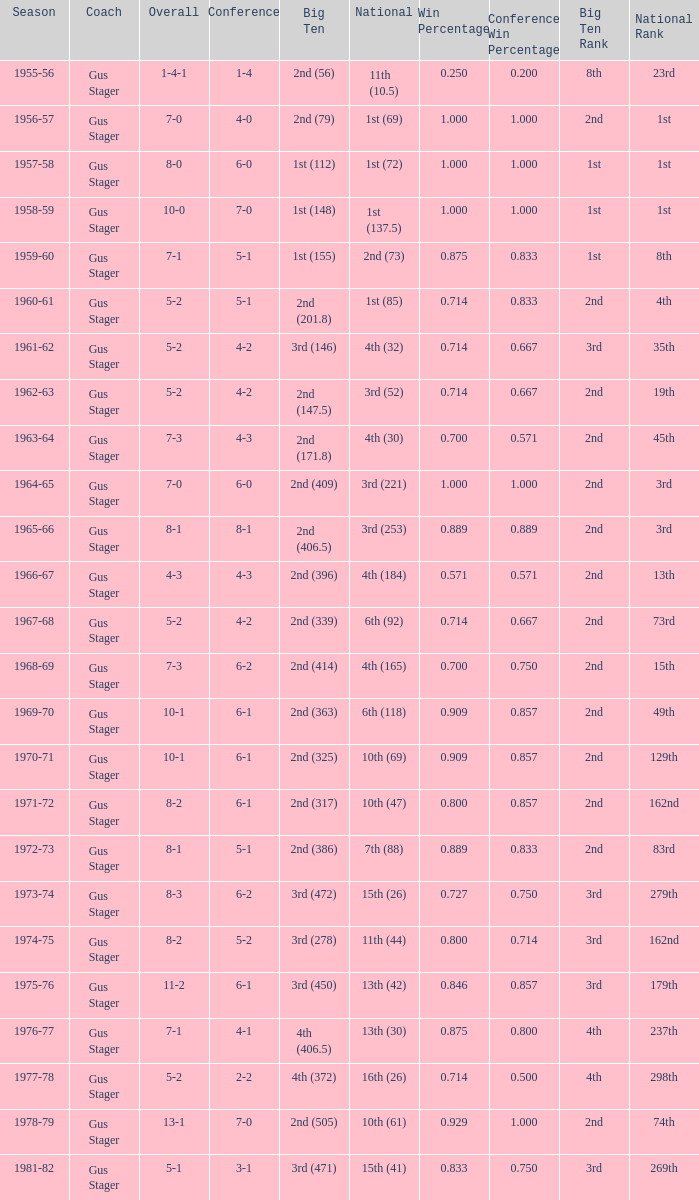What is the Coach with a Big Ten that is 1st (148)? Gus Stager. 